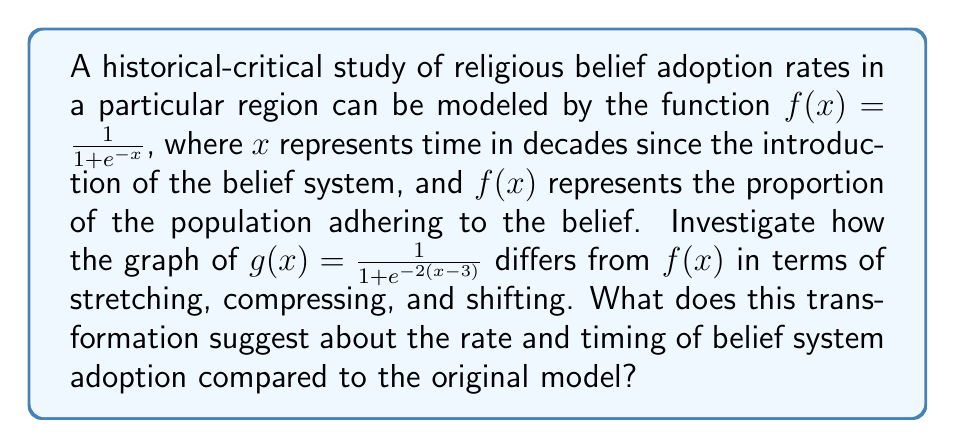Could you help me with this problem? Let's analyze the transformation step-by-step:

1) The original function is $f(x) = \frac{1}{1 + e^{-x}}$, which is the standard logistic function.

2) The new function $g(x) = \frac{1}{1 + e^{-2(x-3)}}$ can be obtained from $f(x)$ through the following transformations:

   a) First, consider the inner function: $-2(x-3)$
      This can be rewritten as $-2x + 6$

   b) The coefficient of $x$ is $-2$, which indicates a horizontal compression by a factor of 2.

   c) The $+6$ inside the exponential is equivalent to a horizontal shift of 3 units to the right (since $6/2 = 3$).

3) Therefore, compared to $f(x)$, the graph of $g(x)$ is:
   - Compressed horizontally by a factor of 2
   - Shifted 3 units to the right

4) Interpretation in context:
   - The horizontal compression by a factor of 2 suggests that the rate of adoption is twice as fast as the original model.
   - The shift of 3 units to the right indicates that the onset of significant adoption is delayed by 3 decades compared to the original model.

5) The transformation doesn't affect the vertical scale, so the final proportion of adopters remains the same as in the original model.

This transformation suggests a delayed but more rapid adoption of the belief system compared to the original historical-critical model.
Answer: Horizontally compressed by factor of 2, shifted 3 units right; indicates delayed but faster adoption. 